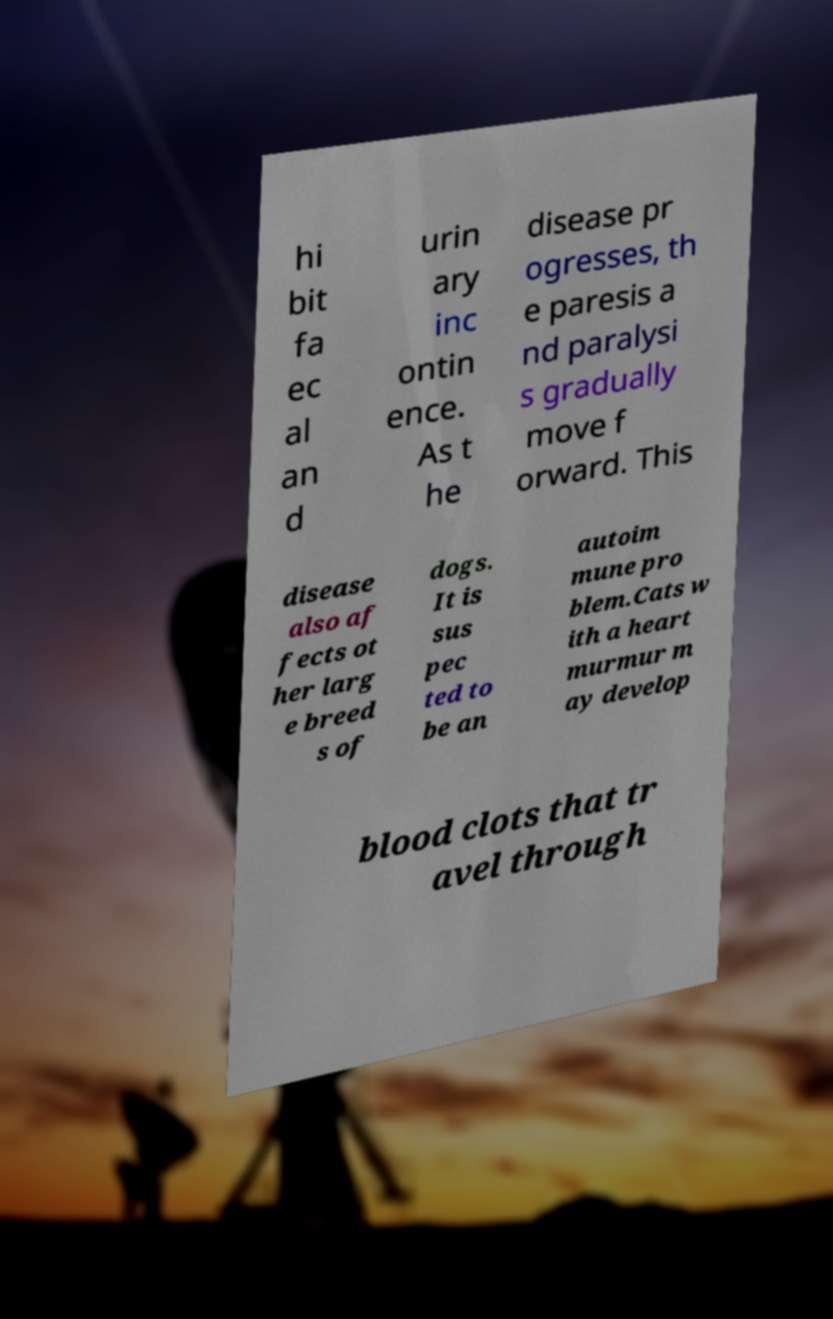I need the written content from this picture converted into text. Can you do that? hi bit fa ec al an d urin ary inc ontin ence. As t he disease pr ogresses, th e paresis a nd paralysi s gradually move f orward. This disease also af fects ot her larg e breed s of dogs. It is sus pec ted to be an autoim mune pro blem.Cats w ith a heart murmur m ay develop blood clots that tr avel through 